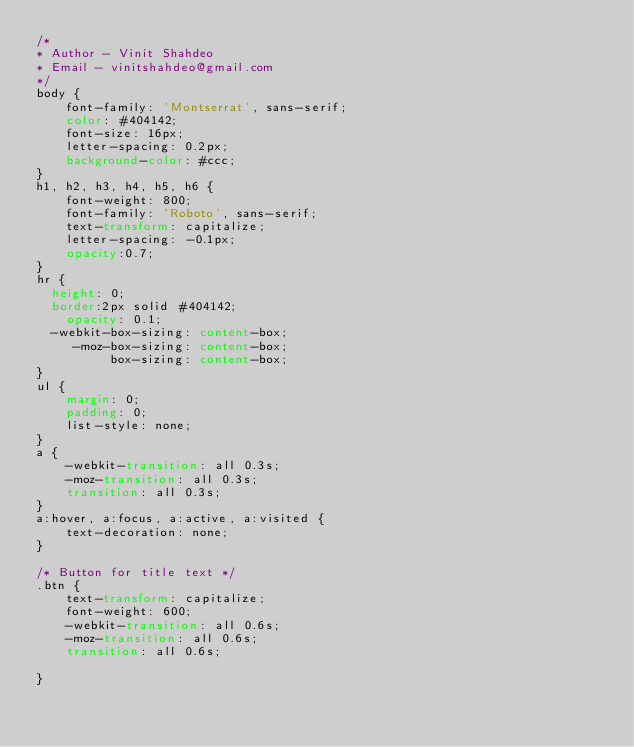Convert code to text. <code><loc_0><loc_0><loc_500><loc_500><_CSS_>/*
* Author - Vinit Shahdeo
* Email - vinitshahdeo@gmail.com
*/
body {
	font-family: 'Montserrat', sans-serif;
    color: #404142;
    font-size: 16px;
    letter-spacing: 0.2px;
    background-color: #ccc;
}
h1, h2, h3, h4, h5, h6 {
	font-weight: 800;
    font-family: 'Roboto', sans-serif;
    text-transform: capitalize;
    letter-spacing: -0.1px;
    opacity:0.7;
}
hr {
  height: 0;
  border:2px solid #404142;
    opacity: 0.1;
  -webkit-box-sizing: content-box;
     -moz-box-sizing: content-box;
          box-sizing: content-box;
}
ul {
	margin: 0;
	padding: 0;
	list-style: none;
}
a {
	-webkit-transition: all 0.3s;
  	-moz-transition: all 0.3s;
  	transition: all 0.3s;
}
a:hover, a:focus, a:active, a:visited {
    text-decoration: none;
}

/* Button for title text */
.btn {
	text-transform: capitalize;
    font-weight: 600;
    -webkit-transition: all 0.6s;
    -moz-transition: all 0.6s;
    transition: all 0.6s;
    
}</code> 